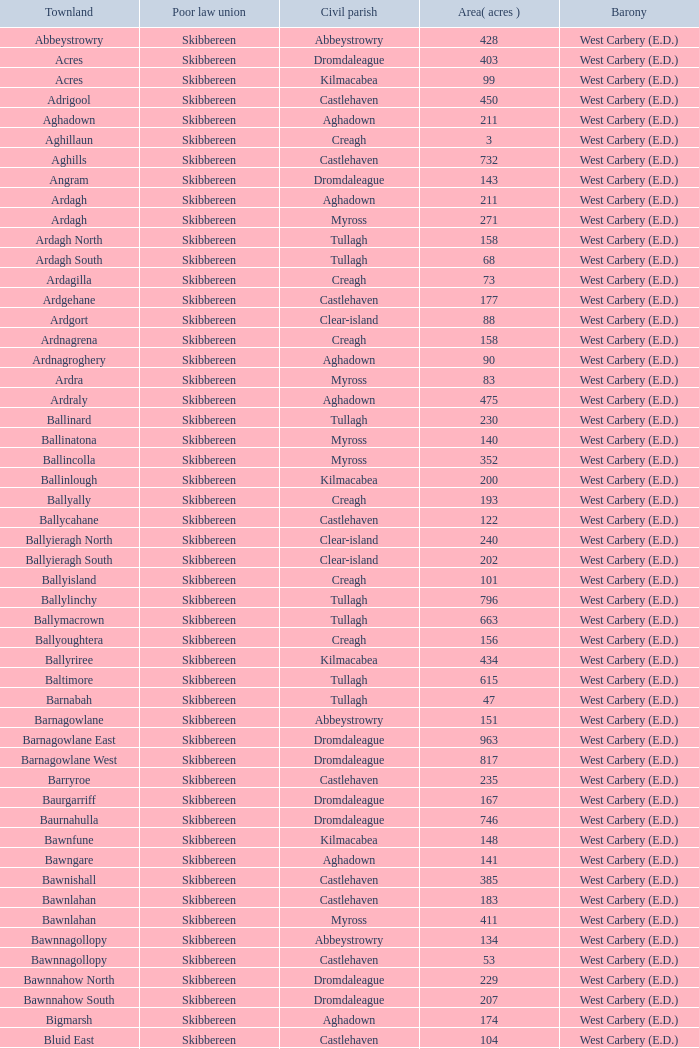What is the greatest area when the Poor Law Union is Skibbereen and the Civil Parish is Tullagh? 796.0. 